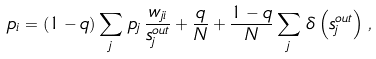Convert formula to latex. <formula><loc_0><loc_0><loc_500><loc_500>p _ { i } = \left ( 1 - q \right ) \sum _ { j } \, p _ { j } \, \frac { w _ { j i } } { s _ { j } ^ { o u t } } + \frac { q } { N } + \frac { 1 - q } { N } \sum _ { j } \, \delta \left ( s _ { j } ^ { o u t } \right ) \, ,</formula> 